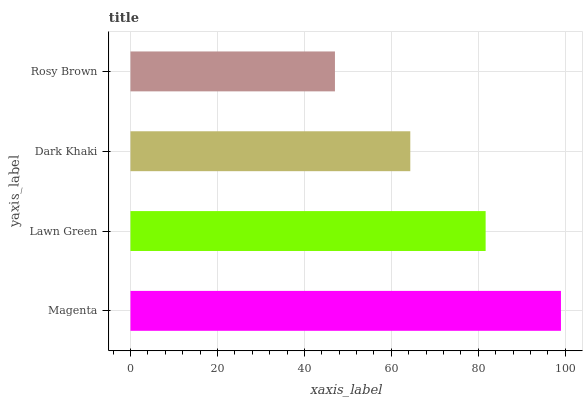Is Rosy Brown the minimum?
Answer yes or no. Yes. Is Magenta the maximum?
Answer yes or no. Yes. Is Lawn Green the minimum?
Answer yes or no. No. Is Lawn Green the maximum?
Answer yes or no. No. Is Magenta greater than Lawn Green?
Answer yes or no. Yes. Is Lawn Green less than Magenta?
Answer yes or no. Yes. Is Lawn Green greater than Magenta?
Answer yes or no. No. Is Magenta less than Lawn Green?
Answer yes or no. No. Is Lawn Green the high median?
Answer yes or no. Yes. Is Dark Khaki the low median?
Answer yes or no. Yes. Is Dark Khaki the high median?
Answer yes or no. No. Is Lawn Green the low median?
Answer yes or no. No. 